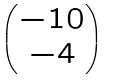Convert formula to latex. <formula><loc_0><loc_0><loc_500><loc_500>\begin{pmatrix} - 1 0 \\ - 4 \end{pmatrix}</formula> 